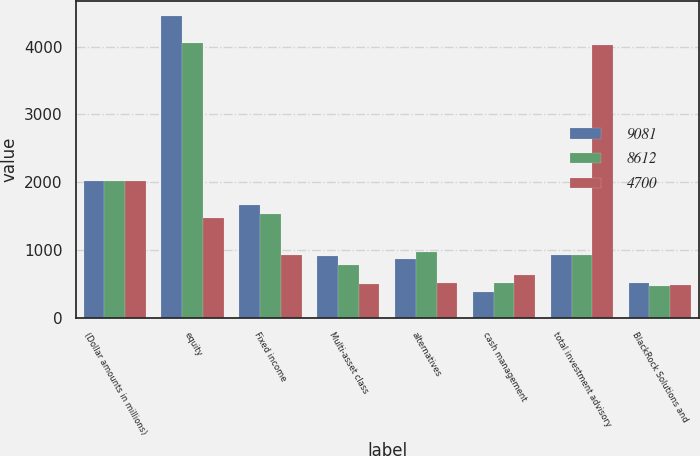Convert chart. <chart><loc_0><loc_0><loc_500><loc_500><stacked_bar_chart><ecel><fcel>(Dollar amounts in millions)<fcel>equity<fcel>Fixed income<fcel>Multi-asset class<fcel>alternatives<fcel>cash management<fcel>total investment advisory<fcel>BlackRock Solutions and<nl><fcel>9081<fcel>2011<fcel>4447<fcel>1659<fcel>914<fcel>864<fcel>383<fcel>917.5<fcel>510<nl><fcel>8612<fcel>2010<fcel>4055<fcel>1531<fcel>773<fcel>961<fcel>510<fcel>917.5<fcel>460<nl><fcel>4700<fcel>2009<fcel>1468<fcel>921<fcel>499<fcel>515<fcel>625<fcel>4028<fcel>477<nl></chart> 